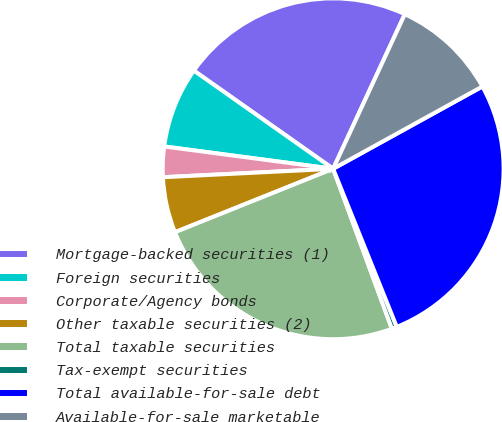Convert chart to OTSL. <chart><loc_0><loc_0><loc_500><loc_500><pie_chart><fcel>Mortgage-backed securities (1)<fcel>Foreign securities<fcel>Corporate/Agency bonds<fcel>Other taxable securities (2)<fcel>Total taxable securities<fcel>Tax-exempt securities<fcel>Total available-for-sale debt<fcel>Available-for-sale marketable<nl><fcel>22.14%<fcel>7.68%<fcel>2.88%<fcel>5.28%<fcel>24.53%<fcel>0.49%<fcel>26.93%<fcel>10.07%<nl></chart> 